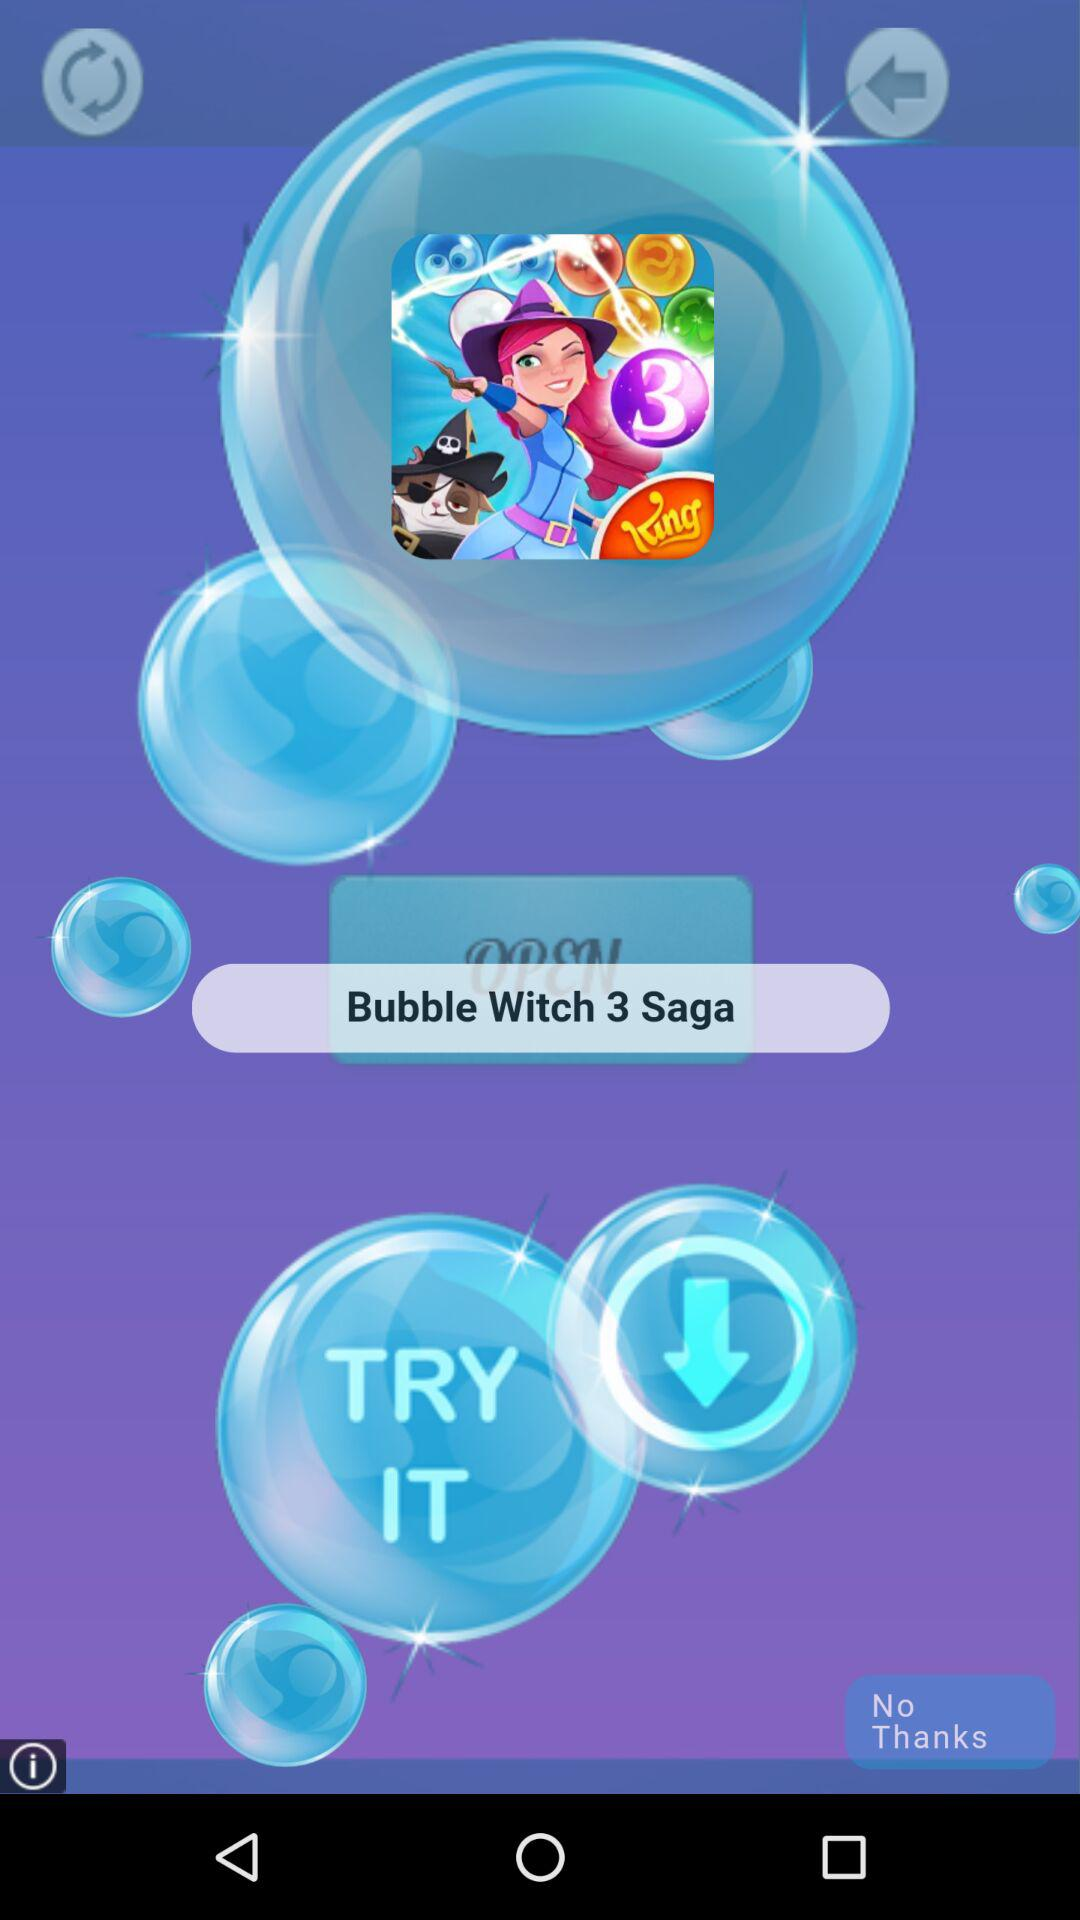How many bubble witch has saga?
When the provided information is insufficient, respond with <no answer>. <no answer> 